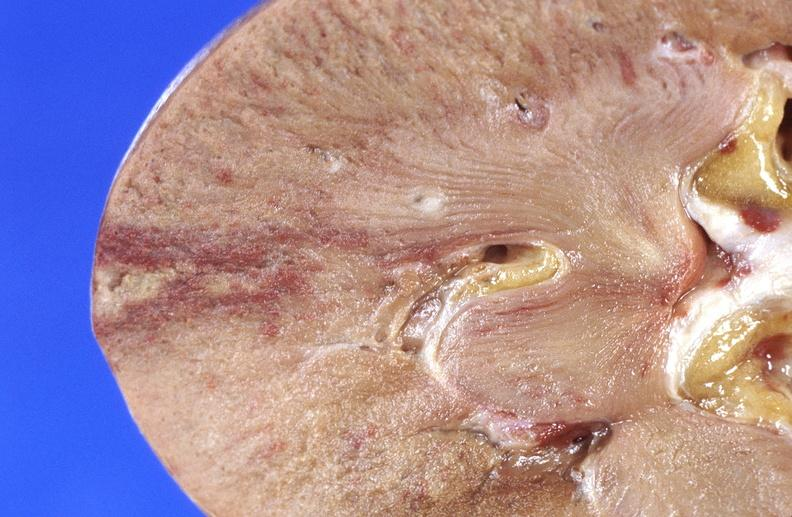what does this image show?
Answer the question using a single word or phrase. Kidney infarct 